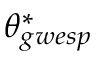Convert formula to latex. <formula><loc_0><loc_0><loc_500><loc_500>\theta _ { g w e s p } ^ { * }</formula> 